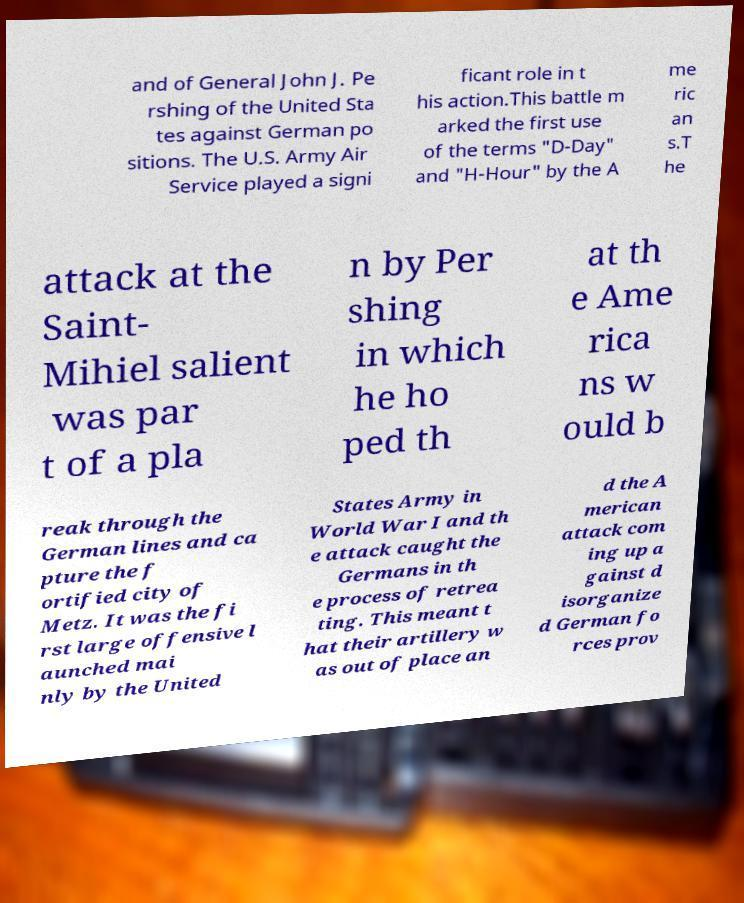I need the written content from this picture converted into text. Can you do that? and of General John J. Pe rshing of the United Sta tes against German po sitions. The U.S. Army Air Service played a signi ficant role in t his action.This battle m arked the first use of the terms "D-Day" and "H-Hour" by the A me ric an s.T he attack at the Saint- Mihiel salient was par t of a pla n by Per shing in which he ho ped th at th e Ame rica ns w ould b reak through the German lines and ca pture the f ortified city of Metz. It was the fi rst large offensive l aunched mai nly by the United States Army in World War I and th e attack caught the Germans in th e process of retrea ting. This meant t hat their artillery w as out of place an d the A merican attack com ing up a gainst d isorganize d German fo rces prov 